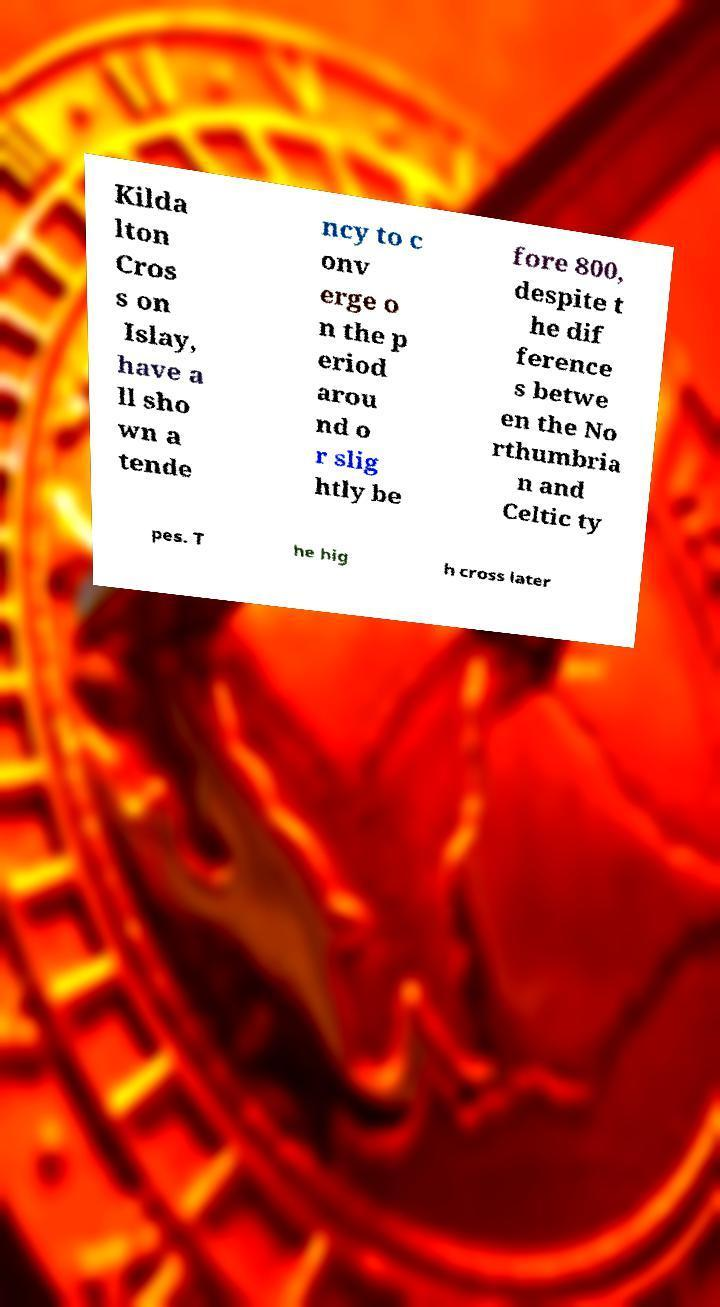I need the written content from this picture converted into text. Can you do that? Kilda lton Cros s on Islay, have a ll sho wn a tende ncy to c onv erge o n the p eriod arou nd o r slig htly be fore 800, despite t he dif ference s betwe en the No rthumbria n and Celtic ty pes. T he hig h cross later 